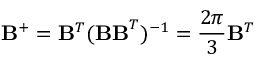<formula> <loc_0><loc_0><loc_500><loc_500>{ B } ^ { + } = { B } ^ { T } ( { B B } ^ { T } ) ^ { - 1 } = \frac { 2 \pi } { 3 } { B } ^ { T }</formula> 